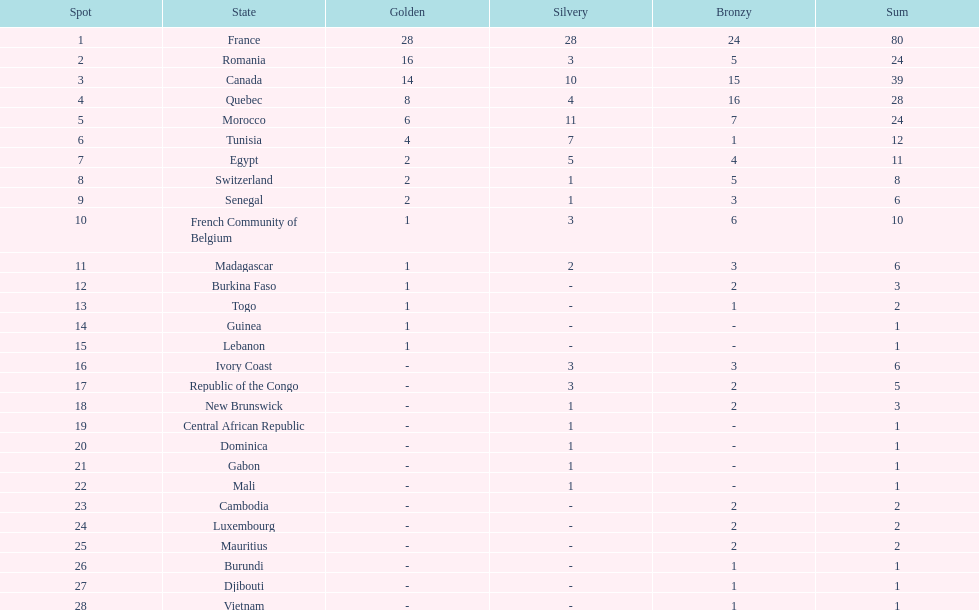How many bronze medals does togo have? 1. 